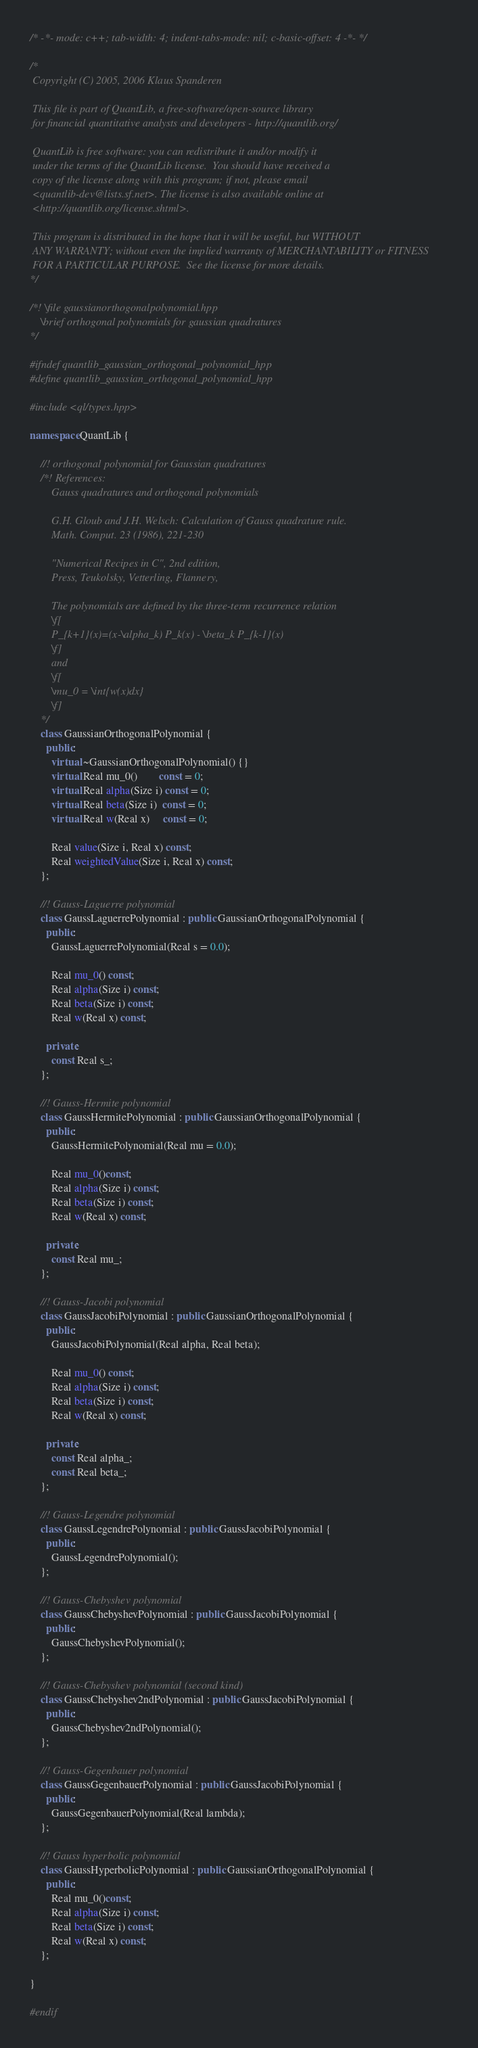<code> <loc_0><loc_0><loc_500><loc_500><_C++_>/* -*- mode: c++; tab-width: 4; indent-tabs-mode: nil; c-basic-offset: 4 -*- */

/*
 Copyright (C) 2005, 2006 Klaus Spanderen

 This file is part of QuantLib, a free-software/open-source library
 for financial quantitative analysts and developers - http://quantlib.org/

 QuantLib is free software: you can redistribute it and/or modify it
 under the terms of the QuantLib license.  You should have received a
 copy of the license along with this program; if not, please email
 <quantlib-dev@lists.sf.net>. The license is also available online at
 <http://quantlib.org/license.shtml>.

 This program is distributed in the hope that it will be useful, but WITHOUT
 ANY WARRANTY; without even the implied warranty of MERCHANTABILITY or FITNESS
 FOR A PARTICULAR PURPOSE.  See the license for more details.
*/

/*! \file gaussianorthogonalpolynomial.hpp
    \brief orthogonal polynomials for gaussian quadratures
*/

#ifndef quantlib_gaussian_orthogonal_polynomial_hpp
#define quantlib_gaussian_orthogonal_polynomial_hpp

#include <ql/types.hpp>

namespace QuantLib {

    //! orthogonal polynomial for Gaussian quadratures
    /*! References:
        Gauss quadratures and orthogonal polynomials

        G.H. Gloub and J.H. Welsch: Calculation of Gauss quadrature rule.
        Math. Comput. 23 (1986), 221-230

        "Numerical Recipes in C", 2nd edition,
        Press, Teukolsky, Vetterling, Flannery,

        The polynomials are defined by the three-term recurrence relation
        \f[
        P_{k+1}(x)=(x-\alpha_k) P_k(x) - \beta_k P_{k-1}(x)
        \f]
        and
        \f[
        \mu_0 = \int{w(x)dx}
        \f]
    */
    class GaussianOrthogonalPolynomial {
      public:
        virtual ~GaussianOrthogonalPolynomial() {}
        virtual Real mu_0()        const = 0;
        virtual Real alpha(Size i) const = 0;
        virtual Real beta(Size i)  const = 0;
        virtual Real w(Real x)     const = 0;

        Real value(Size i, Real x) const;
        Real weightedValue(Size i, Real x) const;
    };

    //! Gauss-Laguerre polynomial
    class GaussLaguerrePolynomial : public GaussianOrthogonalPolynomial {
      public:
        GaussLaguerrePolynomial(Real s = 0.0);

        Real mu_0() const;
        Real alpha(Size i) const;
        Real beta(Size i) const;
        Real w(Real x) const;

      private:
        const Real s_;
    };

    //! Gauss-Hermite polynomial
    class GaussHermitePolynomial : public GaussianOrthogonalPolynomial {
      public:
        GaussHermitePolynomial(Real mu = 0.0);

        Real mu_0()const;
        Real alpha(Size i) const;
        Real beta(Size i) const;
        Real w(Real x) const;

      private:
        const Real mu_;
    };

    //! Gauss-Jacobi polynomial
    class GaussJacobiPolynomial : public GaussianOrthogonalPolynomial {
      public:
        GaussJacobiPolynomial(Real alpha, Real beta);

        Real mu_0() const;
        Real alpha(Size i) const;
        Real beta(Size i) const;
        Real w(Real x) const;

      private:
        const Real alpha_;
        const Real beta_;
    };

    //! Gauss-Legendre polynomial
    class GaussLegendrePolynomial : public GaussJacobiPolynomial {
      public:
        GaussLegendrePolynomial();
    };

    //! Gauss-Chebyshev polynomial
    class GaussChebyshevPolynomial : public GaussJacobiPolynomial {
      public:
        GaussChebyshevPolynomial();
    };

    //! Gauss-Chebyshev polynomial (second kind)
    class GaussChebyshev2ndPolynomial : public GaussJacobiPolynomial {
      public:
        GaussChebyshev2ndPolynomial();
    };

    //! Gauss-Gegenbauer polynomial
    class GaussGegenbauerPolynomial : public GaussJacobiPolynomial {
      public:
        GaussGegenbauerPolynomial(Real lambda);
    };

    //! Gauss hyperbolic polynomial
    class GaussHyperbolicPolynomial : public GaussianOrthogonalPolynomial {
      public:
        Real mu_0()const;
        Real alpha(Size i) const;
        Real beta(Size i) const;
        Real w(Real x) const;
    };

}

#endif
</code> 